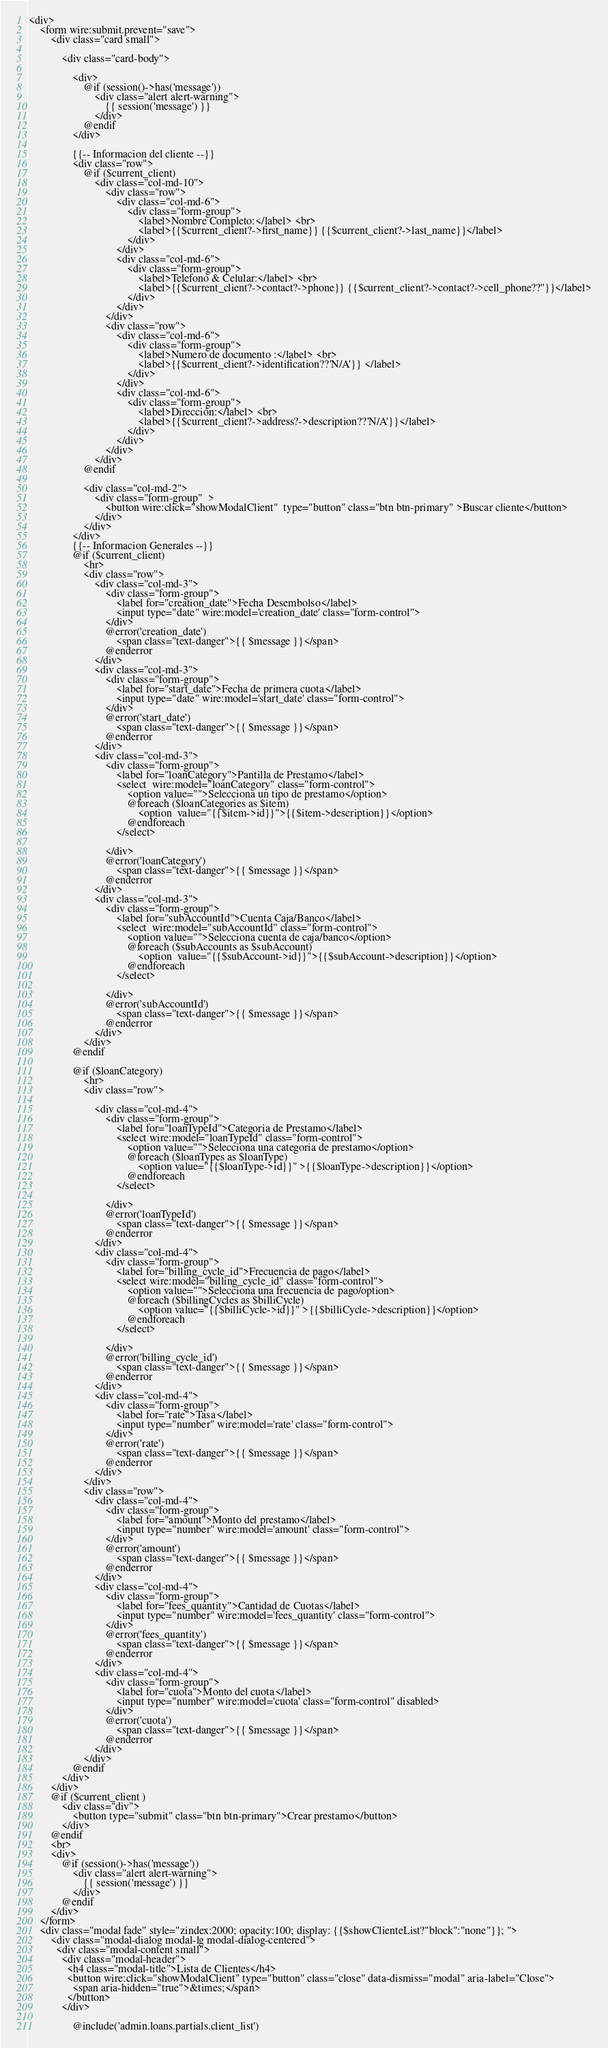<code> <loc_0><loc_0><loc_500><loc_500><_PHP_><div>
    <form wire:submit.prevent="save">
        <div class="card small">

            <div class="card-body">

                <div>
                    @if (session()->has('message'))
                        <div class="alert alert-warning">
                            {{ session('message') }}
                        </div>
                    @endif
                </div>

                {{-- Informacion del cliente --}}
                <div class="row">
                    @if ($current_client)
                        <div class="col-md-10">
                            <div class="row">
                                <div class="col-md-6">
                                    <div class="form-group">
                                        <label>Nombre Completo:</label> <br>
                                        <label>{{$current_client?->first_name}} {{$current_client?->last_name}}</label>
                                    </div>
                                </div>
                                <div class="col-md-6">
                                    <div class="form-group">
                                        <label>Telefono & Celular:</label> <br>
                                        <label>{{$current_client?->contact?->phone}} {{$current_client?->contact?->cell_phone??''}}</label>
                                    </div>
                                </div>
                            </div>
                            <div class="row">
                                <div class="col-md-6">
                                    <div class="form-group">
                                        <label>Numero de documento :</label> <br>
                                        <label>{{$current_client?->identification??'N/A'}} </label>
                                    </div>
                                </div>
                                <div class="col-md-6">
                                    <div class="form-group">
                                        <label>Dirección:</label> <br>
                                        <label>{{$current_client?->address?->description??'N/A'}}</label>
                                    </div>
                                </div>
                            </div>
                        </div>
                    @endif

                    <div class="col-md-2">
                        <div class="form-group"  >
                            <button wire:click="showModalClient"  type="button" class="btn btn-primary" >Buscar cliente</button>
                        </div>
                    </div>
                </div>
                {{-- Informacion Generales --}}
                @if ($current_client)
                    <hr>
                    <div class="row">
                        <div class="col-md-3">
                            <div class="form-group">
                                <label for="creation_date">Fecha Desembolso</label>
                                <input type="date" wire:model='creation_date' class="form-control">
                            </div>
                            @error('creation_date')
                                <span class="text-danger">{{ $message }}</span>
                            @enderror
                        </div>
                        <div class="col-md-3">
                            <div class="form-group">
                                <label for="start_date">Fecha de primera cuota</label>
                                <input type="date" wire:model='start_date' class="form-control">
                            </div>
                            @error('start_date')
                                <span class="text-danger">{{ $message }}</span>
                            @enderror
                        </div>
                        <div class="col-md-3">
                            <div class="form-group">
                                <label for="loanCategory">Pantilla de Prestamo</label>
                                <select  wire:model="loanCategory" class="form-control">
                                    <option value="">Selecciona un tipo de prestamo</option>
                                    @foreach ($loanCategories as $item)
                                        <option  value="{{$item->id}}">{{$item->description}}</option>
                                    @endforeach
                                </select>

                            </div>
                            @error('loanCategory')
                                <span class="text-danger">{{ $message }}</span>
                            @enderror
                        </div>
                        <div class="col-md-3">
                            <div class="form-group">
                                <label for="subAccountId">Cuenta Caja/Banco</label>
                                <select  wire:model="subAccountId" class="form-control">
                                    <option value="">Selecciona cuenta de caja/banco</option>
                                    @foreach ($subAccounts as $subAccount)
                                        <option  value="{{$subAccount->id}}">{{$subAccount->description}}</option>
                                    @endforeach
                                </select>

                            </div>
                            @error('subAccountId')
                                <span class="text-danger">{{ $message }}</span>
                            @enderror
                        </div>
                    </div>
                @endif

                @if ($loanCategory)
                    <hr>
                    <div class="row">

                        <div class="col-md-4">
                            <div class="form-group">
                                <label for="loanTypeId">Categoria de Prestamo</label>
                                <select wire:model="loanTypeId" class="form-control">
                                    <option value="">Selecciona una categoria de prestamo</option>
                                    @foreach ($loanTypes as $loanType)
                                        <option value="{{$loanType->id}}" >{{$loanType->description}}</option>
                                    @endforeach
                                </select>

                            </div>
                            @error('loanTypeId')
                                <span class="text-danger">{{ $message }}</span>
                            @enderror
                        </div>
                        <div class="col-md-4">
                            <div class="form-group">
                                <label for="billing_cycle_id">Frecuencia de pago</label>
                                <select wire:model="billing_cycle_id" class="form-control">
                                    <option value="">Selecciona una frecuencia de pago/option>
                                    @foreach ($billingCycles as $billiCycle)
                                        <option value="{{$billiCycle->id}}" >{{$billiCycle->description}}</option>
                                    @endforeach
                                </select>

                            </div>
                            @error('billing_cycle_id')
                                <span class="text-danger">{{ $message }}</span>
                            @enderror
                        </div>
                        <div class="col-md-4">
                            <div class="form-group">
                                <label for="rate">Tasa</label>
                                <input type="number" wire:model='rate' class="form-control">
                            </div>
                            @error('rate')
                                <span class="text-danger">{{ $message }}</span>
                            @enderror
                        </div>
                    </div>
                    <div class="row">
                        <div class="col-md-4">
                            <div class="form-group">
                                <label for="amount">Monto del prestamo</label>
                                <input type="number" wire:model='amount' class="form-control">
                            </div>
                            @error('amount')
                                <span class="text-danger">{{ $message }}</span>
                            @enderror
                        </div>
                        <div class="col-md-4">
                            <div class="form-group">
                                <label for="fees_quantity">Cantidad de Cuotas</label>
                                <input type="number" wire:model='fees_quantity' class="form-control">
                            </div>
                            @error('fees_quantity')
                                <span class="text-danger">{{ $message }}</span>
                            @enderror
                        </div>
                        <div class="col-md-4">
                            <div class="form-group">
                                <label for="cuota">Monto del cuota</label>
                                <input type="number" wire:model='cuota' class="form-control" disabled>
                            </div>
                            @error('cuota')
                                <span class="text-danger">{{ $message }}</span>
                            @enderror
                        </div>
                    </div>
                @endif
            </div>
        </div>
        @if ($current_client )
            <div class="div">
                <button type="submit" class="btn btn-primary">Crear prestamo</button>
            </div>
        @endif
        <br>
        <div>
            @if (session()->has('message'))
                <div class="alert alert-warning">
                    {{ session('message') }}
                </div>
            @endif
        </div>
    </form>
    <div class="modal fade" style="zindex:2000; opacity:100; display: {{$showClienteList?"block":"none"}}; ">
        <div class="modal-dialog modal-lg modal-dialog-centered">
          <div class="modal-content small">
            <div class="modal-header">
              <h4 class="modal-title">Lista de Clientes</h4>
              <button wire:click="showModalClient" type="button" class="close" data-dismiss="modal" aria-label="Close">
                <span aria-hidden="true">&times;</span>
              </button>
            </div>

                @include('admin.loans.partials.client_list')
</code> 